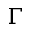<formula> <loc_0><loc_0><loc_500><loc_500>\Gamma</formula> 